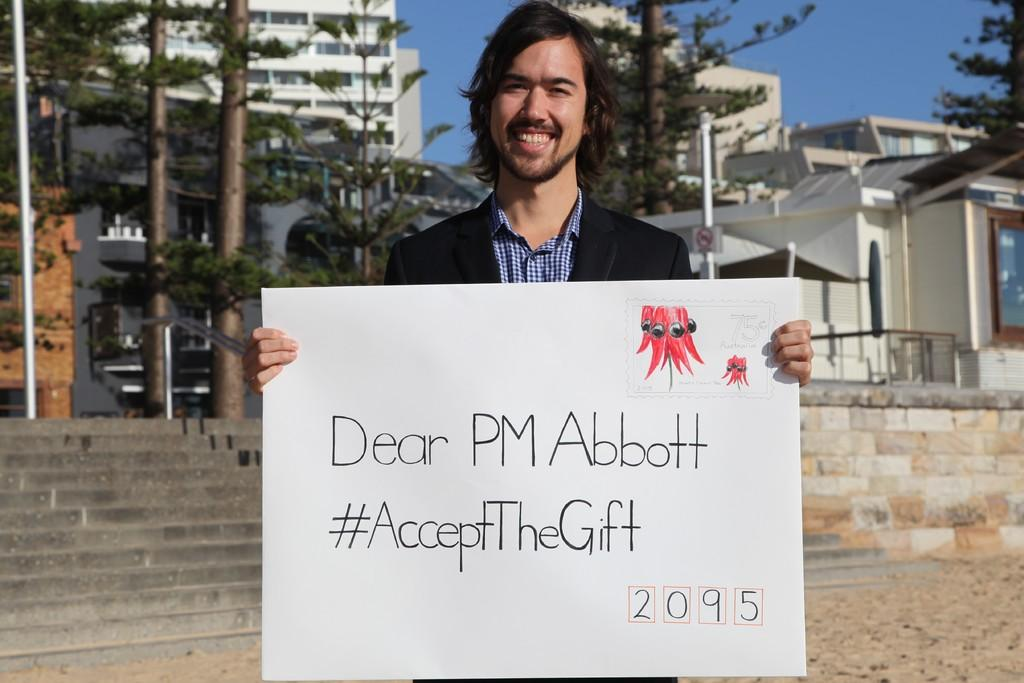What is the man in the image holding? The man is holding a poster in the image. What can be seen in the background of the image? In the background of the image, there are stairs, trees, poles, and buildings. What is visible at the top of the image? The sky is visible at the top of the image. What type of machine is the man using to express regret in the image? There is no machine or expression of regret present in the image; the man is simply holding a poster. 